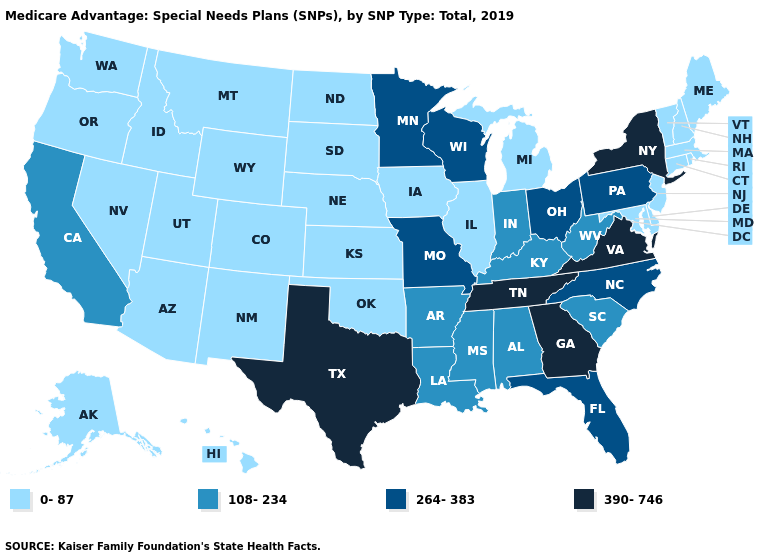Which states have the lowest value in the MidWest?
Answer briefly. Illinois, Iowa, Kansas, Michigan, Nebraska, North Dakota, South Dakota. Among the states that border Tennessee , which have the highest value?
Be succinct. Georgia, Virginia. What is the lowest value in states that border Nevada?
Write a very short answer. 0-87. What is the value of Florida?
Be succinct. 264-383. What is the value of Ohio?
Answer briefly. 264-383. Name the states that have a value in the range 0-87?
Short answer required. Alaska, Arizona, Colorado, Connecticut, Delaware, Hawaii, Idaho, Illinois, Iowa, Kansas, Maine, Maryland, Massachusetts, Michigan, Montana, Nebraska, Nevada, New Hampshire, New Jersey, New Mexico, North Dakota, Oklahoma, Oregon, Rhode Island, South Dakota, Utah, Vermont, Washington, Wyoming. How many symbols are there in the legend?
Quick response, please. 4. What is the value of Washington?
Keep it brief. 0-87. Does Wisconsin have the same value as Louisiana?
Quick response, please. No. What is the value of Colorado?
Short answer required. 0-87. Is the legend a continuous bar?
Keep it brief. No. Name the states that have a value in the range 264-383?
Keep it brief. Florida, Minnesota, Missouri, North Carolina, Ohio, Pennsylvania, Wisconsin. Name the states that have a value in the range 108-234?
Be succinct. Alabama, Arkansas, California, Indiana, Kentucky, Louisiana, Mississippi, South Carolina, West Virginia. Does Arizona have a lower value than South Dakota?
Give a very brief answer. No. Does Connecticut have the highest value in the Northeast?
Answer briefly. No. 